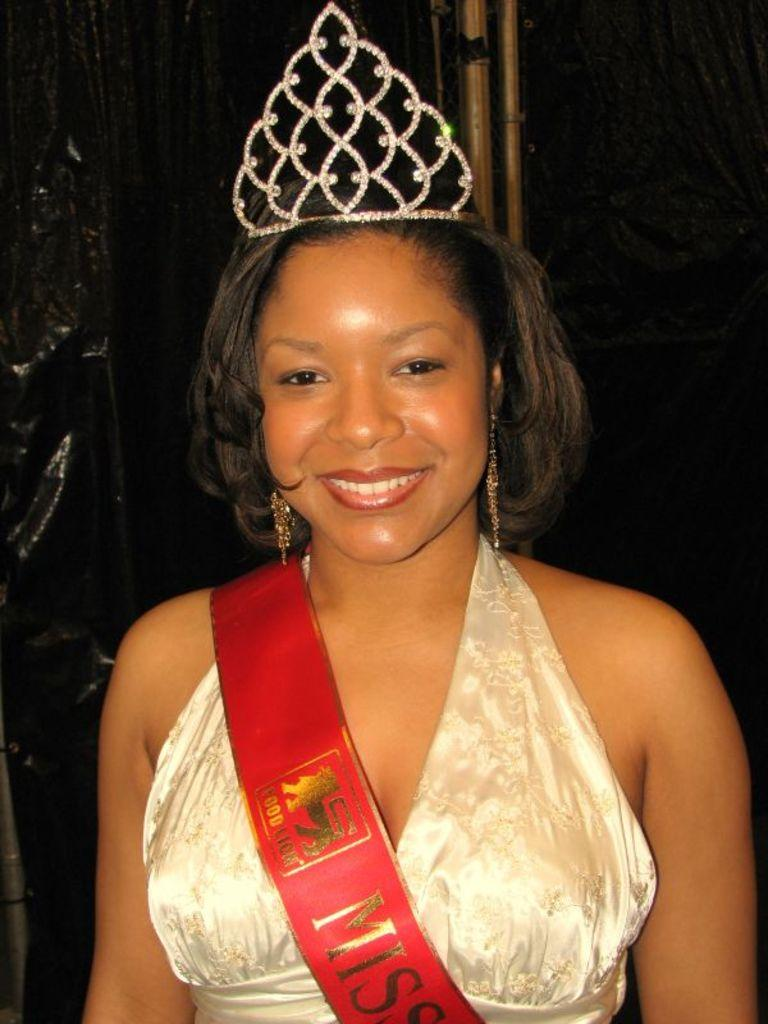Who is present in the image? There is a woman in the image. What expression does the woman have? The woman is smiling. What accessories is the woman wearing? The woman is wearing a crown and earrings. What type of treatment is the monkey receiving on the street in the image? There is no monkey or street present in the image; it features a woman wearing a crown and earrings. 